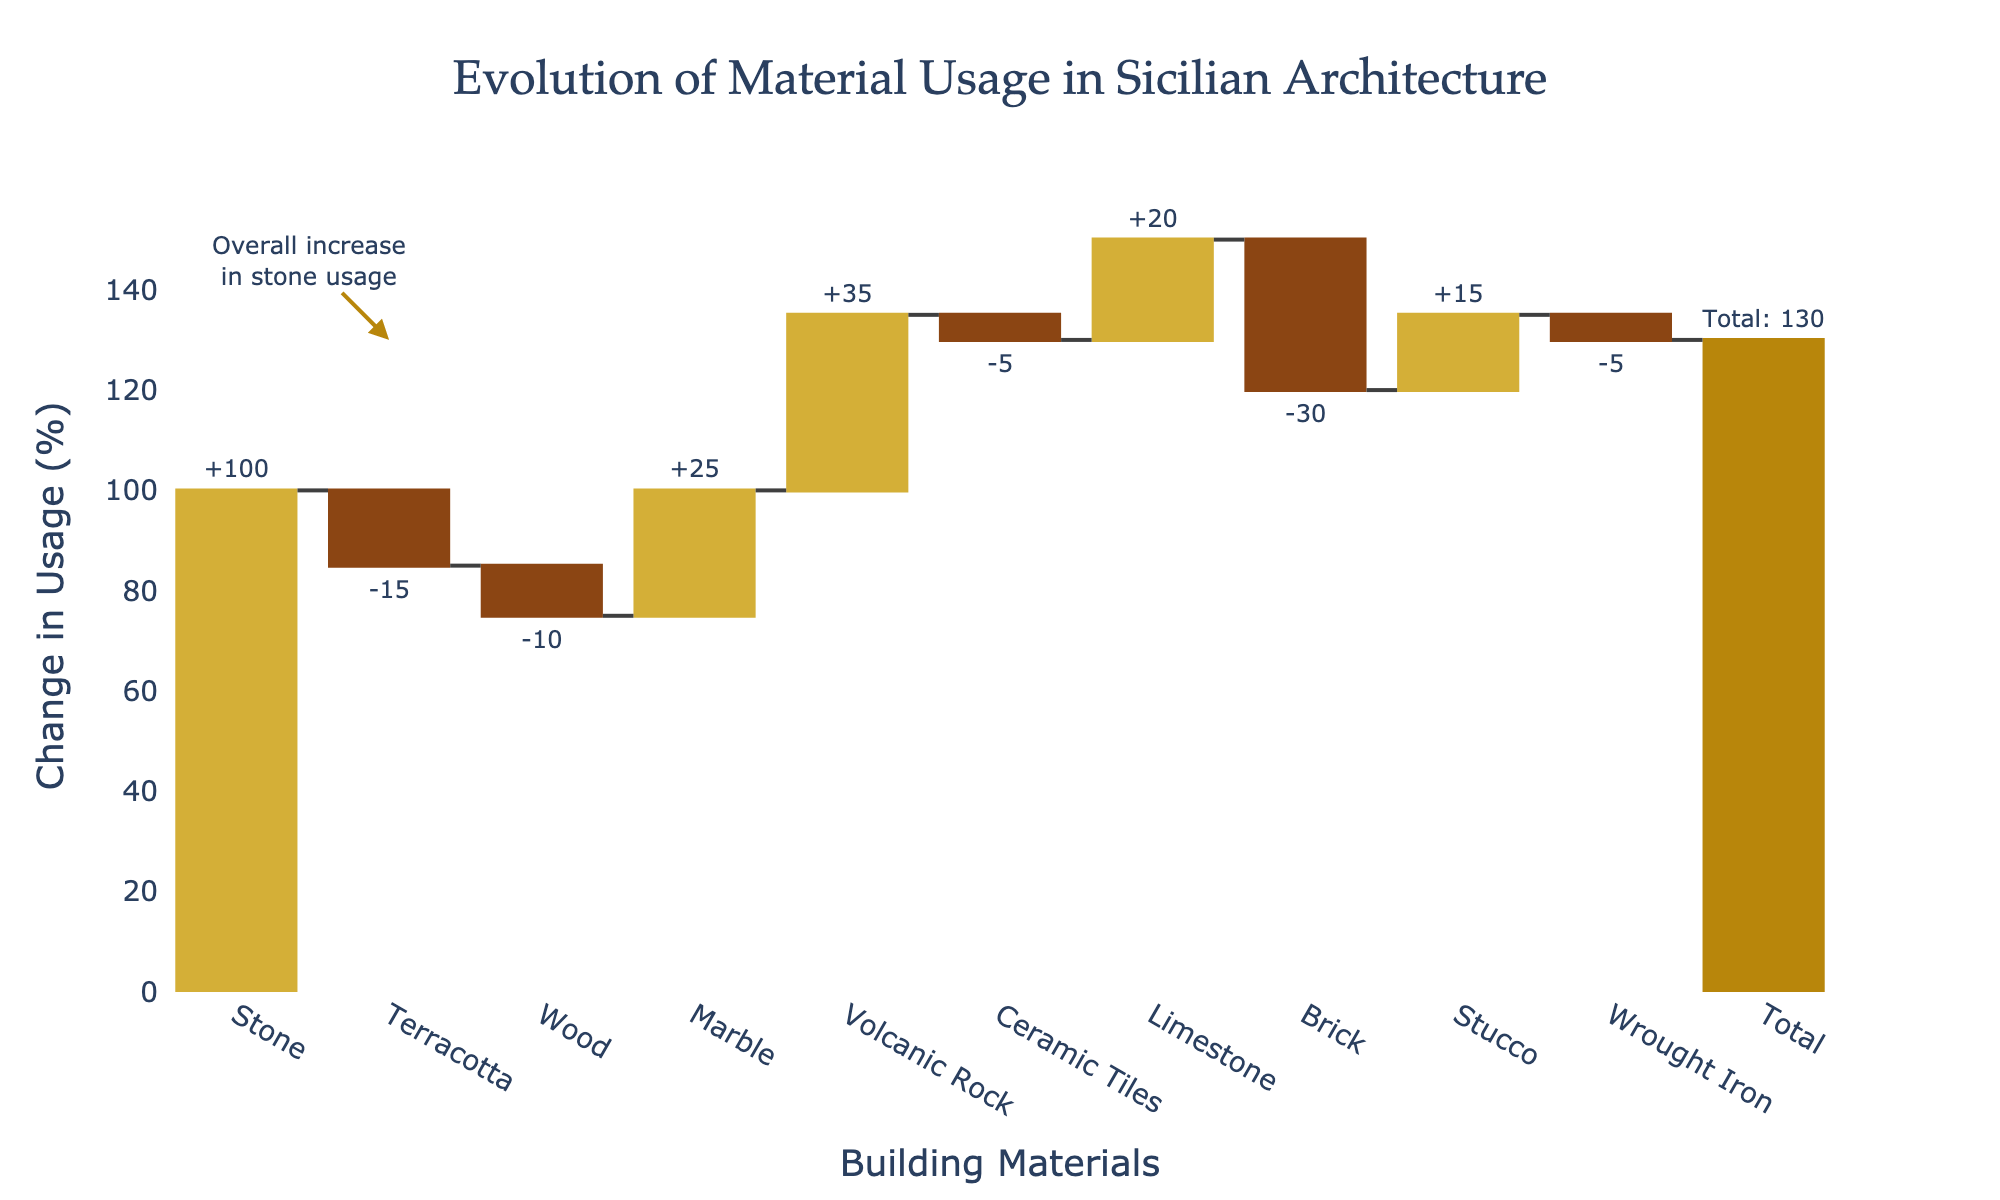What is the title of the figure? The title of the figure is usually placed at the top center of the chart. For this chart, the title is displayed prominently in a larger font.
Answer: Evolution of Material Usage in Sicilian Architecture What is the y-axis title on the figure? The y-axis title is displayed vertically along the left side of the chart. It provides context for what the values on the y-axis represent.
Answer: Change in Usage (%) How many types of materials are analyzed in the chart? Each unique material is displayed on the x-axis as distinct labels. Counting these labels will give the number of materials analyzed.
Answer: 10 Which material has the highest positive change in usage? By looking at the height and position of the bars above the x-axis, you can determine which material shows the highest positive change.
Answer: Stone What is the total change in material usage? The total change is usually displayed as a separate bar or annotated in the chart. In this case, the chart has a specific annotation for total change.
Answer: 130 Which materials saw a decrease in usage? Bars that fall below the x-axis represent a decrease in usage. Identifying these bars will reveal the materials that experienced a decrease.
Answer: Terracotta, Wood, Ceramic Tiles, Brick, Wrought Iron What is the net change in usage for Wood and Stucco combined? First, identify the change in usage for Wood and Stucco individually. Then, add these values to get the net change. Change in usage for Wood = -10, for Stucco = 15. Adding these values: -10 + 15 = 5.
Answer: 5 How does the change in Marble usage compare to the change in Limestone usage? By looking at the height and relative position of these two bars, you can see if one is higher (more positive) or lower (less positive).
Answer: Marble has a smaller increase than Limestone Which material saw the second-highest increase in usage? After identifying the material with the highest increase, determine which material has the next highest bar above the x-axis.
Answer: Volcanic Rock What annotation is added to the figure and what does it signify? The annotation is usually highlighted with an arrow or text box on the chart. It signifies an important aspect of the data, in this case indicating an overall trend or significant change.
Answer: Overall increase in stone usage 